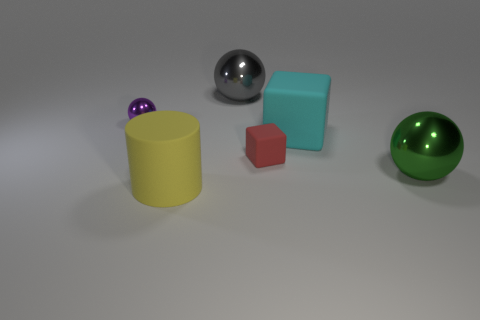Does the big thing on the right side of the cyan block have the same material as the big sphere on the left side of the small matte cube?
Your response must be concise. Yes. There is a small metal object; how many cyan matte cubes are in front of it?
Keep it short and to the point. 1. What number of red objects are small rubber things or large metallic objects?
Provide a succinct answer. 1. There is a yellow cylinder that is the same size as the gray object; what is its material?
Your answer should be compact. Rubber. There is a metallic object that is right of the large yellow object and to the left of the tiny cube; what is its shape?
Provide a succinct answer. Sphere. The other metallic thing that is the same size as the green metallic object is what color?
Ensure brevity in your answer.  Gray. There is a rubber object that is in front of the large green sphere; is it the same size as the red block to the right of the small ball?
Your answer should be very brief. No. What size is the purple shiny ball to the left of the ball that is on the right side of the large sphere that is on the left side of the green shiny object?
Provide a short and direct response. Small. There is a big green thing behind the large object left of the gray metal thing; what shape is it?
Offer a terse response. Sphere. Do the sphere on the left side of the cylinder and the big block have the same color?
Offer a terse response. No. 